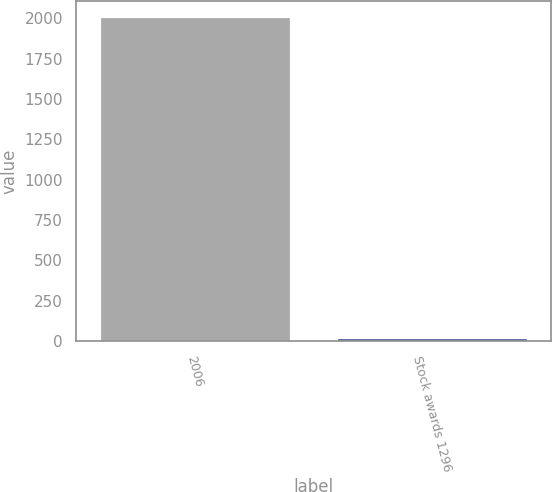Convert chart to OTSL. <chart><loc_0><loc_0><loc_500><loc_500><bar_chart><fcel>2006<fcel>Stock awards 1296<nl><fcel>2007<fcel>18.29<nl></chart> 